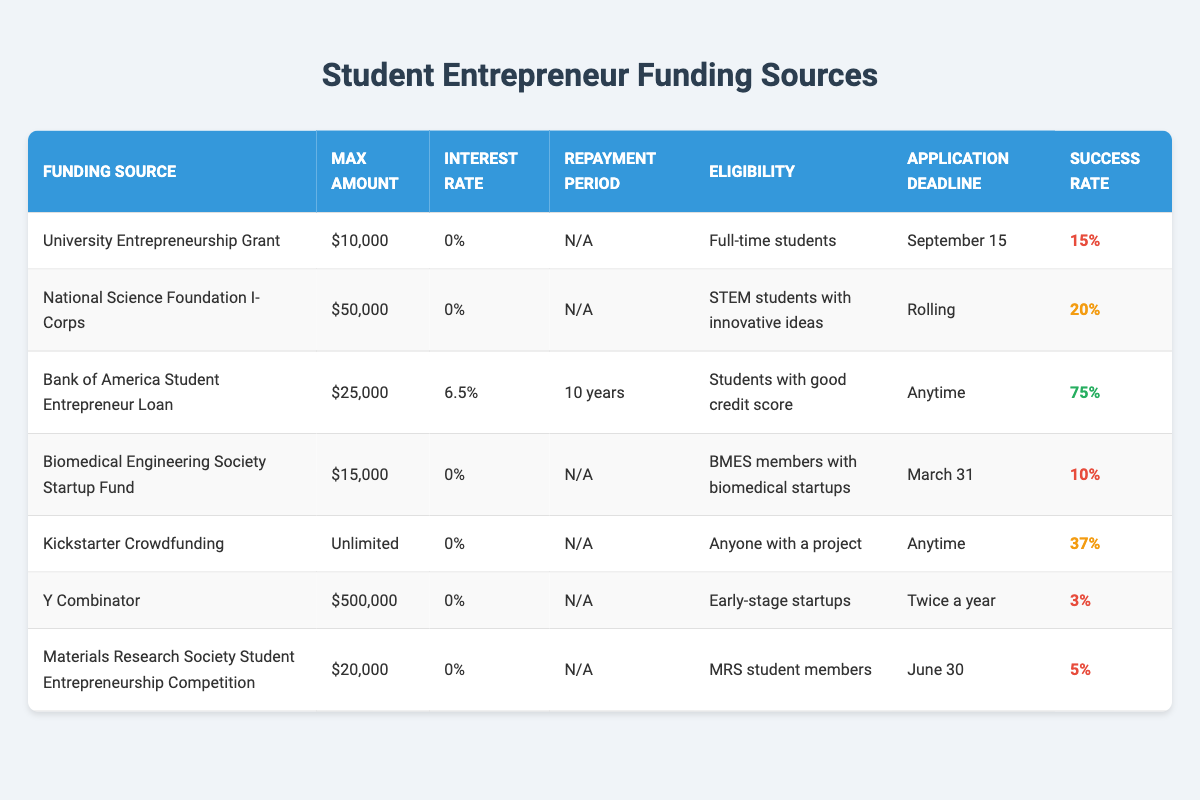What is the maximum amount available from the National Science Foundation I-Corps? The table lists the maximum amounts available for each funding source. For the National Science Foundation I-Corps, the amount specified is $50,000.
Answer: $50,000 Which funding source has the lowest success rate? By examining the success rates provided in the table, the Biomedical Engineering Society Startup Fund has a success rate of 10%, the lowest among all listed sources.
Answer: Biomedical Engineering Society Startup Fund Are full-time students eligible for the Bank of America Student Entrepreneur Loan? The table indicates that the eligibility requirement for the Bank of America Student Entrepreneur Loan is "Students with good credit score," not full-time students. Thus, the answer is no.
Answer: No What is the average maximum amount among all funding sources listed? The total maximum amounts for the funding sources are $10,000 (University Entrepreneurship Grant) + $50,000 (National Science Foundation I-Corps) + $25,000 (Bank of America Loan) + $15,000 (Biomedical Society Fund) + Unlimited (Kickstarter) + $500,000 (Y Combinator) + $20,000 (MRS Competition) = $620,000 (noting that "Unlimited" isn't defined in a numerical context). Since there are 7 funding sources, we calculate the average as $620,000/7, which doesn't yield a sensible numerical average due to 'Unlimited.' A numerical average excluding "Unlimited" gives ($10,000 + $50,000 + $25,000 + $15,000 + $20,000) / 5 = $14,000.
Answer: Average is undefined due to "Unlimited" or is $14,000 when excluding it What are the application deadlines for the Y Combinator funding source? The table shows that the application deadline for Y Combinator is "Twice a year." This means applications can be submitted biannually, but specific dates are not provided.
Answer: Twice a year 